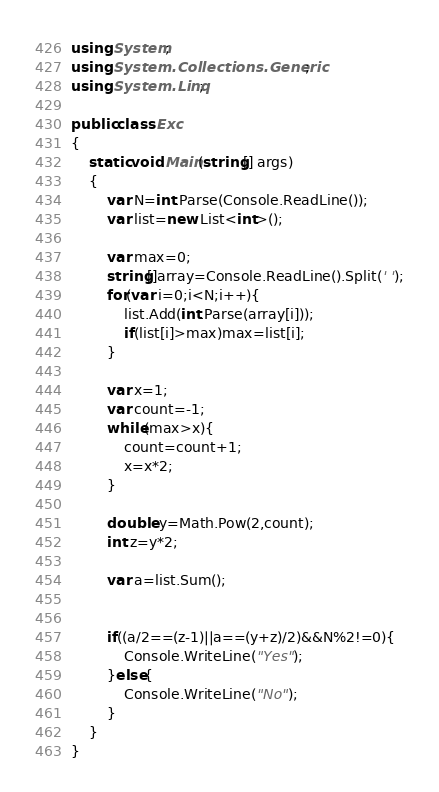<code> <loc_0><loc_0><loc_500><loc_500><_C#_>using System;
using System.Collections.Generic;
using System.Linq;

public class Exc
{
    static void Main(string[] args)
    {
        var N=int.Parse(Console.ReadLine());
        var list=new List<int>();
        
        var max=0;
        string[]array=Console.ReadLine().Split(' ');
        for(var i=0;i<N;i++){
            list.Add(int.Parse(array[i]));
            if(list[i]>max)max=list[i];
        }
        
        var x=1;
        var count=-1;
        while(max>x){
            count=count+1;
            x=x*2;
        }
        
        double y=Math.Pow(2,count);
        int z=y*2;
        
        var a=list.Sum();
        
        
        if((a/2==(z-1)||a==(y+z)/2)&&N%2!=0){
            Console.WriteLine("Yes");
        }else{
            Console.WriteLine("No");
        }
    }
}</code> 